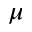<formula> <loc_0><loc_0><loc_500><loc_500>\mu</formula> 